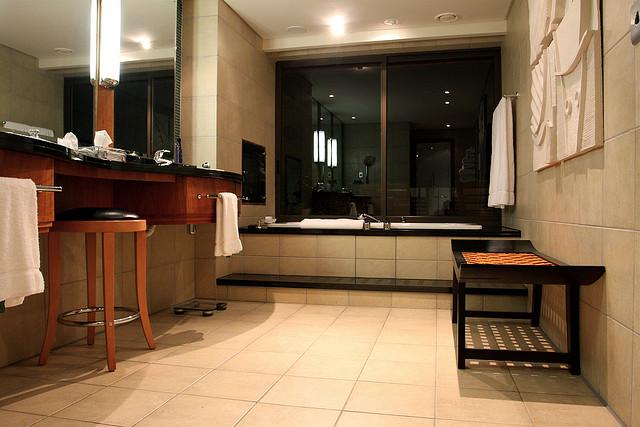Is the floor tile?
Be succinct. Yes. How many towels are hanging?
Answer briefly. 3. Is there a scale visible?
Keep it brief. Yes. 